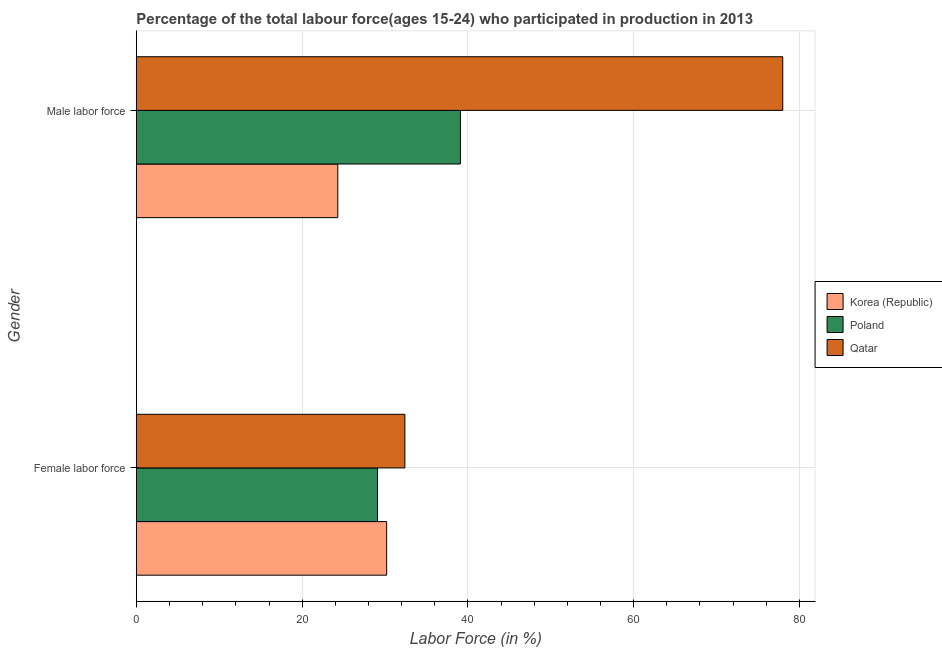How many different coloured bars are there?
Your answer should be very brief. 3. How many groups of bars are there?
Your answer should be compact. 2. Are the number of bars per tick equal to the number of legend labels?
Offer a very short reply. Yes. How many bars are there on the 2nd tick from the bottom?
Your response must be concise. 3. What is the label of the 2nd group of bars from the top?
Keep it short and to the point. Female labor force. What is the percentage of male labour force in Poland?
Ensure brevity in your answer.  39.1. Across all countries, what is the maximum percentage of female labor force?
Offer a very short reply. 32.4. Across all countries, what is the minimum percentage of male labour force?
Your response must be concise. 24.3. In which country was the percentage of male labour force maximum?
Offer a terse response. Qatar. In which country was the percentage of male labour force minimum?
Offer a terse response. Korea (Republic). What is the total percentage of female labor force in the graph?
Keep it short and to the point. 91.7. What is the difference between the percentage of male labour force in Korea (Republic) and that in Qatar?
Provide a succinct answer. -53.7. What is the difference between the percentage of female labor force in Korea (Republic) and the percentage of male labour force in Qatar?
Provide a short and direct response. -47.8. What is the average percentage of female labor force per country?
Your answer should be compact. 30.57. What is the difference between the percentage of female labor force and percentage of male labour force in Korea (Republic)?
Give a very brief answer. 5.9. In how many countries, is the percentage of male labour force greater than 48 %?
Your answer should be compact. 1. What is the ratio of the percentage of female labor force in Qatar to that in Korea (Republic)?
Your response must be concise. 1.07. Is the percentage of female labor force in Korea (Republic) less than that in Qatar?
Make the answer very short. Yes. What does the 1st bar from the top in Male labor force represents?
Provide a short and direct response. Qatar. How many bars are there?
Give a very brief answer. 6. Are all the bars in the graph horizontal?
Your answer should be compact. Yes. How many countries are there in the graph?
Keep it short and to the point. 3. How are the legend labels stacked?
Keep it short and to the point. Vertical. What is the title of the graph?
Offer a very short reply. Percentage of the total labour force(ages 15-24) who participated in production in 2013. What is the label or title of the X-axis?
Your answer should be very brief. Labor Force (in %). What is the Labor Force (in %) in Korea (Republic) in Female labor force?
Keep it short and to the point. 30.2. What is the Labor Force (in %) in Poland in Female labor force?
Your answer should be very brief. 29.1. What is the Labor Force (in %) in Qatar in Female labor force?
Give a very brief answer. 32.4. What is the Labor Force (in %) of Korea (Republic) in Male labor force?
Your answer should be very brief. 24.3. What is the Labor Force (in %) of Poland in Male labor force?
Keep it short and to the point. 39.1. What is the Labor Force (in %) in Qatar in Male labor force?
Provide a succinct answer. 78. Across all Gender, what is the maximum Labor Force (in %) of Korea (Republic)?
Ensure brevity in your answer.  30.2. Across all Gender, what is the maximum Labor Force (in %) in Poland?
Make the answer very short. 39.1. Across all Gender, what is the maximum Labor Force (in %) of Qatar?
Ensure brevity in your answer.  78. Across all Gender, what is the minimum Labor Force (in %) of Korea (Republic)?
Keep it short and to the point. 24.3. Across all Gender, what is the minimum Labor Force (in %) in Poland?
Provide a short and direct response. 29.1. Across all Gender, what is the minimum Labor Force (in %) of Qatar?
Your response must be concise. 32.4. What is the total Labor Force (in %) of Korea (Republic) in the graph?
Provide a short and direct response. 54.5. What is the total Labor Force (in %) in Poland in the graph?
Give a very brief answer. 68.2. What is the total Labor Force (in %) in Qatar in the graph?
Offer a very short reply. 110.4. What is the difference between the Labor Force (in %) in Poland in Female labor force and that in Male labor force?
Your answer should be compact. -10. What is the difference between the Labor Force (in %) in Qatar in Female labor force and that in Male labor force?
Keep it short and to the point. -45.6. What is the difference between the Labor Force (in %) of Korea (Republic) in Female labor force and the Labor Force (in %) of Poland in Male labor force?
Make the answer very short. -8.9. What is the difference between the Labor Force (in %) in Korea (Republic) in Female labor force and the Labor Force (in %) in Qatar in Male labor force?
Give a very brief answer. -47.8. What is the difference between the Labor Force (in %) of Poland in Female labor force and the Labor Force (in %) of Qatar in Male labor force?
Give a very brief answer. -48.9. What is the average Labor Force (in %) of Korea (Republic) per Gender?
Provide a short and direct response. 27.25. What is the average Labor Force (in %) in Poland per Gender?
Ensure brevity in your answer.  34.1. What is the average Labor Force (in %) in Qatar per Gender?
Give a very brief answer. 55.2. What is the difference between the Labor Force (in %) in Korea (Republic) and Labor Force (in %) in Poland in Female labor force?
Offer a terse response. 1.1. What is the difference between the Labor Force (in %) of Korea (Republic) and Labor Force (in %) of Qatar in Female labor force?
Keep it short and to the point. -2.2. What is the difference between the Labor Force (in %) in Poland and Labor Force (in %) in Qatar in Female labor force?
Your answer should be very brief. -3.3. What is the difference between the Labor Force (in %) of Korea (Republic) and Labor Force (in %) of Poland in Male labor force?
Ensure brevity in your answer.  -14.8. What is the difference between the Labor Force (in %) in Korea (Republic) and Labor Force (in %) in Qatar in Male labor force?
Ensure brevity in your answer.  -53.7. What is the difference between the Labor Force (in %) in Poland and Labor Force (in %) in Qatar in Male labor force?
Offer a very short reply. -38.9. What is the ratio of the Labor Force (in %) in Korea (Republic) in Female labor force to that in Male labor force?
Provide a succinct answer. 1.24. What is the ratio of the Labor Force (in %) of Poland in Female labor force to that in Male labor force?
Give a very brief answer. 0.74. What is the ratio of the Labor Force (in %) in Qatar in Female labor force to that in Male labor force?
Offer a very short reply. 0.42. What is the difference between the highest and the second highest Labor Force (in %) in Poland?
Make the answer very short. 10. What is the difference between the highest and the second highest Labor Force (in %) of Qatar?
Provide a succinct answer. 45.6. What is the difference between the highest and the lowest Labor Force (in %) of Korea (Republic)?
Your response must be concise. 5.9. What is the difference between the highest and the lowest Labor Force (in %) in Poland?
Offer a terse response. 10. What is the difference between the highest and the lowest Labor Force (in %) in Qatar?
Provide a succinct answer. 45.6. 